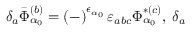Convert formula to latex. <formula><loc_0><loc_0><loc_500><loc_500>\delta _ { a } \bar { \Phi } _ { \alpha _ { 0 } } ^ { ( b ) } = \left ( - \right ) ^ { \epsilon _ { \alpha _ { 0 } } } \varepsilon _ { a b c } \Phi _ { \alpha _ { 0 } } ^ { * ( c ) } , \, \delta _ { a }</formula> 